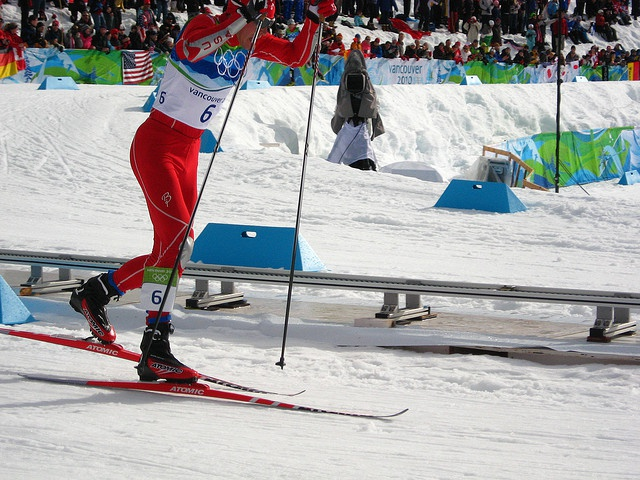Describe the objects in this image and their specific colors. I can see people in brown, maroon, black, and darkgray tones, people in brown, black, darkgray, gray, and maroon tones, skis in brown, lightgray, darkgray, maroon, and gray tones, people in brown, black, gray, and darkgray tones, and skis in brown, gray, darkgray, and lightgray tones in this image. 